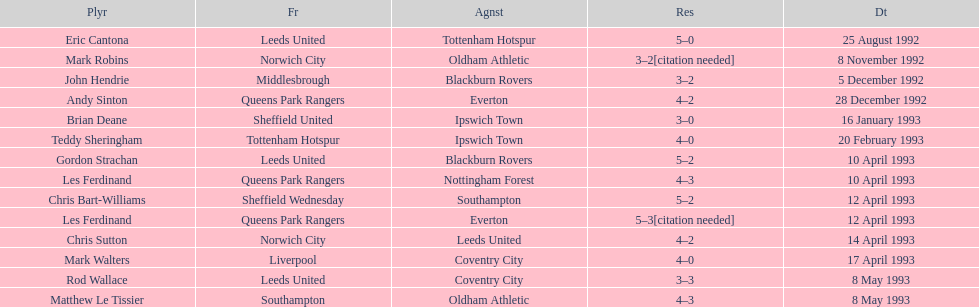Which player had the same result as mark robins? John Hendrie. 